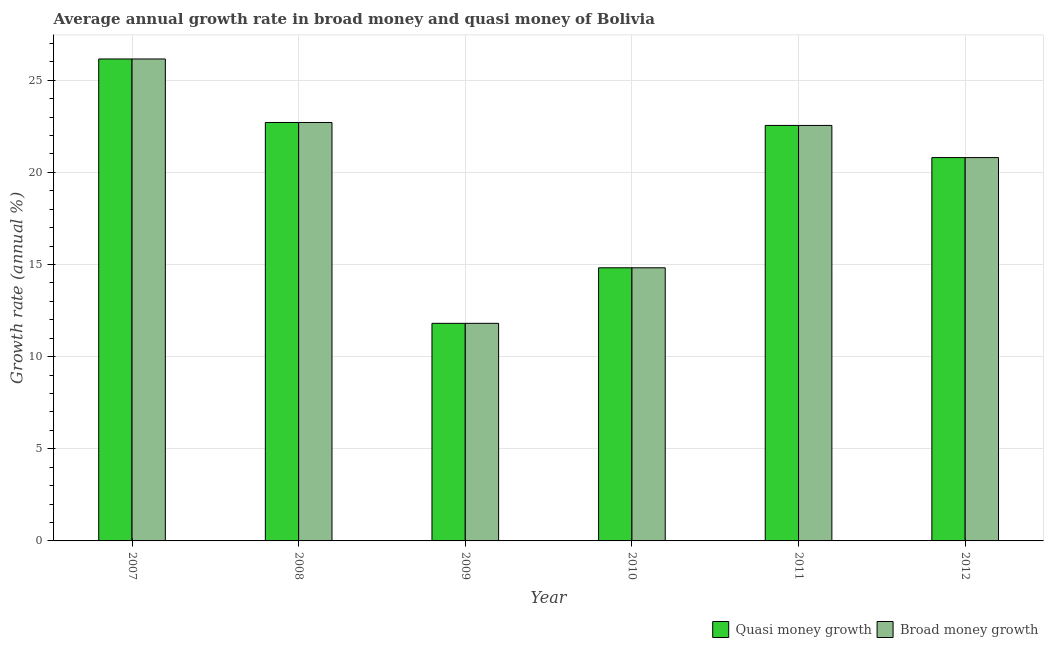How many bars are there on the 5th tick from the left?
Provide a short and direct response. 2. What is the label of the 1st group of bars from the left?
Offer a very short reply. 2007. In how many cases, is the number of bars for a given year not equal to the number of legend labels?
Ensure brevity in your answer.  0. What is the annual growth rate in broad money in 2011?
Offer a terse response. 22.55. Across all years, what is the maximum annual growth rate in quasi money?
Give a very brief answer. 26.15. Across all years, what is the minimum annual growth rate in broad money?
Ensure brevity in your answer.  11.81. In which year was the annual growth rate in broad money minimum?
Give a very brief answer. 2009. What is the total annual growth rate in broad money in the graph?
Keep it short and to the point. 118.83. What is the difference between the annual growth rate in broad money in 2007 and that in 2008?
Your answer should be compact. 3.45. What is the difference between the annual growth rate in quasi money in 2009 and the annual growth rate in broad money in 2007?
Offer a very short reply. -14.34. What is the average annual growth rate in quasi money per year?
Give a very brief answer. 19.8. What is the ratio of the annual growth rate in quasi money in 2009 to that in 2010?
Provide a short and direct response. 0.8. What is the difference between the highest and the second highest annual growth rate in broad money?
Your answer should be very brief. 3.45. What is the difference between the highest and the lowest annual growth rate in quasi money?
Give a very brief answer. 14.34. Is the sum of the annual growth rate in broad money in 2009 and 2010 greater than the maximum annual growth rate in quasi money across all years?
Provide a short and direct response. Yes. What does the 2nd bar from the left in 2010 represents?
Your answer should be compact. Broad money growth. What does the 2nd bar from the right in 2010 represents?
Provide a succinct answer. Quasi money growth. Are all the bars in the graph horizontal?
Your answer should be very brief. No. How many years are there in the graph?
Your answer should be very brief. 6. What is the difference between two consecutive major ticks on the Y-axis?
Provide a succinct answer. 5. Are the values on the major ticks of Y-axis written in scientific E-notation?
Your response must be concise. No. Does the graph contain any zero values?
Offer a very short reply. No. Does the graph contain grids?
Your response must be concise. Yes. How are the legend labels stacked?
Provide a short and direct response. Horizontal. What is the title of the graph?
Your answer should be compact. Average annual growth rate in broad money and quasi money of Bolivia. Does "Import" appear as one of the legend labels in the graph?
Offer a very short reply. No. What is the label or title of the X-axis?
Keep it short and to the point. Year. What is the label or title of the Y-axis?
Provide a succinct answer. Growth rate (annual %). What is the Growth rate (annual %) in Quasi money growth in 2007?
Offer a terse response. 26.15. What is the Growth rate (annual %) of Broad money growth in 2007?
Provide a succinct answer. 26.15. What is the Growth rate (annual %) of Quasi money growth in 2008?
Your answer should be very brief. 22.7. What is the Growth rate (annual %) in Broad money growth in 2008?
Make the answer very short. 22.7. What is the Growth rate (annual %) in Quasi money growth in 2009?
Your answer should be very brief. 11.81. What is the Growth rate (annual %) in Broad money growth in 2009?
Your answer should be compact. 11.81. What is the Growth rate (annual %) of Quasi money growth in 2010?
Give a very brief answer. 14.82. What is the Growth rate (annual %) in Broad money growth in 2010?
Offer a very short reply. 14.82. What is the Growth rate (annual %) in Quasi money growth in 2011?
Make the answer very short. 22.55. What is the Growth rate (annual %) of Broad money growth in 2011?
Your answer should be very brief. 22.55. What is the Growth rate (annual %) in Quasi money growth in 2012?
Your answer should be very brief. 20.8. What is the Growth rate (annual %) of Broad money growth in 2012?
Provide a short and direct response. 20.8. Across all years, what is the maximum Growth rate (annual %) of Quasi money growth?
Your answer should be very brief. 26.15. Across all years, what is the maximum Growth rate (annual %) in Broad money growth?
Ensure brevity in your answer.  26.15. Across all years, what is the minimum Growth rate (annual %) in Quasi money growth?
Your answer should be very brief. 11.81. Across all years, what is the minimum Growth rate (annual %) of Broad money growth?
Give a very brief answer. 11.81. What is the total Growth rate (annual %) in Quasi money growth in the graph?
Provide a short and direct response. 118.83. What is the total Growth rate (annual %) in Broad money growth in the graph?
Keep it short and to the point. 118.83. What is the difference between the Growth rate (annual %) of Quasi money growth in 2007 and that in 2008?
Offer a very short reply. 3.45. What is the difference between the Growth rate (annual %) of Broad money growth in 2007 and that in 2008?
Give a very brief answer. 3.45. What is the difference between the Growth rate (annual %) of Quasi money growth in 2007 and that in 2009?
Make the answer very short. 14.34. What is the difference between the Growth rate (annual %) in Broad money growth in 2007 and that in 2009?
Provide a succinct answer. 14.34. What is the difference between the Growth rate (annual %) in Quasi money growth in 2007 and that in 2010?
Offer a very short reply. 11.33. What is the difference between the Growth rate (annual %) in Broad money growth in 2007 and that in 2010?
Your answer should be compact. 11.33. What is the difference between the Growth rate (annual %) of Quasi money growth in 2007 and that in 2011?
Make the answer very short. 3.61. What is the difference between the Growth rate (annual %) in Broad money growth in 2007 and that in 2011?
Provide a succinct answer. 3.61. What is the difference between the Growth rate (annual %) in Quasi money growth in 2007 and that in 2012?
Offer a very short reply. 5.35. What is the difference between the Growth rate (annual %) in Broad money growth in 2007 and that in 2012?
Your answer should be very brief. 5.35. What is the difference between the Growth rate (annual %) in Quasi money growth in 2008 and that in 2009?
Keep it short and to the point. 10.9. What is the difference between the Growth rate (annual %) of Broad money growth in 2008 and that in 2009?
Your answer should be very brief. 10.9. What is the difference between the Growth rate (annual %) of Quasi money growth in 2008 and that in 2010?
Give a very brief answer. 7.88. What is the difference between the Growth rate (annual %) of Broad money growth in 2008 and that in 2010?
Your answer should be compact. 7.88. What is the difference between the Growth rate (annual %) of Quasi money growth in 2008 and that in 2011?
Keep it short and to the point. 0.16. What is the difference between the Growth rate (annual %) of Broad money growth in 2008 and that in 2011?
Your answer should be very brief. 0.16. What is the difference between the Growth rate (annual %) of Quasi money growth in 2008 and that in 2012?
Provide a short and direct response. 1.9. What is the difference between the Growth rate (annual %) in Broad money growth in 2008 and that in 2012?
Provide a succinct answer. 1.9. What is the difference between the Growth rate (annual %) in Quasi money growth in 2009 and that in 2010?
Your answer should be compact. -3.01. What is the difference between the Growth rate (annual %) in Broad money growth in 2009 and that in 2010?
Your response must be concise. -3.01. What is the difference between the Growth rate (annual %) of Quasi money growth in 2009 and that in 2011?
Ensure brevity in your answer.  -10.74. What is the difference between the Growth rate (annual %) of Broad money growth in 2009 and that in 2011?
Offer a terse response. -10.74. What is the difference between the Growth rate (annual %) in Quasi money growth in 2009 and that in 2012?
Make the answer very short. -8.99. What is the difference between the Growth rate (annual %) in Broad money growth in 2009 and that in 2012?
Ensure brevity in your answer.  -8.99. What is the difference between the Growth rate (annual %) in Quasi money growth in 2010 and that in 2011?
Your answer should be compact. -7.72. What is the difference between the Growth rate (annual %) of Broad money growth in 2010 and that in 2011?
Your response must be concise. -7.72. What is the difference between the Growth rate (annual %) in Quasi money growth in 2010 and that in 2012?
Your answer should be very brief. -5.98. What is the difference between the Growth rate (annual %) in Broad money growth in 2010 and that in 2012?
Make the answer very short. -5.98. What is the difference between the Growth rate (annual %) in Quasi money growth in 2011 and that in 2012?
Ensure brevity in your answer.  1.75. What is the difference between the Growth rate (annual %) of Broad money growth in 2011 and that in 2012?
Offer a very short reply. 1.75. What is the difference between the Growth rate (annual %) in Quasi money growth in 2007 and the Growth rate (annual %) in Broad money growth in 2008?
Make the answer very short. 3.45. What is the difference between the Growth rate (annual %) in Quasi money growth in 2007 and the Growth rate (annual %) in Broad money growth in 2009?
Make the answer very short. 14.34. What is the difference between the Growth rate (annual %) of Quasi money growth in 2007 and the Growth rate (annual %) of Broad money growth in 2010?
Offer a terse response. 11.33. What is the difference between the Growth rate (annual %) in Quasi money growth in 2007 and the Growth rate (annual %) in Broad money growth in 2011?
Your answer should be compact. 3.61. What is the difference between the Growth rate (annual %) of Quasi money growth in 2007 and the Growth rate (annual %) of Broad money growth in 2012?
Make the answer very short. 5.35. What is the difference between the Growth rate (annual %) in Quasi money growth in 2008 and the Growth rate (annual %) in Broad money growth in 2009?
Your answer should be compact. 10.9. What is the difference between the Growth rate (annual %) in Quasi money growth in 2008 and the Growth rate (annual %) in Broad money growth in 2010?
Provide a succinct answer. 7.88. What is the difference between the Growth rate (annual %) in Quasi money growth in 2008 and the Growth rate (annual %) in Broad money growth in 2011?
Offer a very short reply. 0.16. What is the difference between the Growth rate (annual %) in Quasi money growth in 2008 and the Growth rate (annual %) in Broad money growth in 2012?
Keep it short and to the point. 1.9. What is the difference between the Growth rate (annual %) in Quasi money growth in 2009 and the Growth rate (annual %) in Broad money growth in 2010?
Provide a succinct answer. -3.01. What is the difference between the Growth rate (annual %) of Quasi money growth in 2009 and the Growth rate (annual %) of Broad money growth in 2011?
Provide a short and direct response. -10.74. What is the difference between the Growth rate (annual %) in Quasi money growth in 2009 and the Growth rate (annual %) in Broad money growth in 2012?
Your answer should be very brief. -8.99. What is the difference between the Growth rate (annual %) in Quasi money growth in 2010 and the Growth rate (annual %) in Broad money growth in 2011?
Keep it short and to the point. -7.72. What is the difference between the Growth rate (annual %) in Quasi money growth in 2010 and the Growth rate (annual %) in Broad money growth in 2012?
Make the answer very short. -5.98. What is the difference between the Growth rate (annual %) of Quasi money growth in 2011 and the Growth rate (annual %) of Broad money growth in 2012?
Provide a short and direct response. 1.75. What is the average Growth rate (annual %) in Quasi money growth per year?
Keep it short and to the point. 19.8. What is the average Growth rate (annual %) in Broad money growth per year?
Ensure brevity in your answer.  19.8. In the year 2009, what is the difference between the Growth rate (annual %) in Quasi money growth and Growth rate (annual %) in Broad money growth?
Keep it short and to the point. 0. In the year 2012, what is the difference between the Growth rate (annual %) in Quasi money growth and Growth rate (annual %) in Broad money growth?
Your answer should be very brief. 0. What is the ratio of the Growth rate (annual %) in Quasi money growth in 2007 to that in 2008?
Keep it short and to the point. 1.15. What is the ratio of the Growth rate (annual %) in Broad money growth in 2007 to that in 2008?
Provide a short and direct response. 1.15. What is the ratio of the Growth rate (annual %) in Quasi money growth in 2007 to that in 2009?
Keep it short and to the point. 2.21. What is the ratio of the Growth rate (annual %) in Broad money growth in 2007 to that in 2009?
Your answer should be very brief. 2.21. What is the ratio of the Growth rate (annual %) of Quasi money growth in 2007 to that in 2010?
Offer a terse response. 1.76. What is the ratio of the Growth rate (annual %) in Broad money growth in 2007 to that in 2010?
Ensure brevity in your answer.  1.76. What is the ratio of the Growth rate (annual %) in Quasi money growth in 2007 to that in 2011?
Your answer should be compact. 1.16. What is the ratio of the Growth rate (annual %) in Broad money growth in 2007 to that in 2011?
Your answer should be very brief. 1.16. What is the ratio of the Growth rate (annual %) in Quasi money growth in 2007 to that in 2012?
Provide a short and direct response. 1.26. What is the ratio of the Growth rate (annual %) in Broad money growth in 2007 to that in 2012?
Offer a very short reply. 1.26. What is the ratio of the Growth rate (annual %) of Quasi money growth in 2008 to that in 2009?
Provide a succinct answer. 1.92. What is the ratio of the Growth rate (annual %) of Broad money growth in 2008 to that in 2009?
Give a very brief answer. 1.92. What is the ratio of the Growth rate (annual %) in Quasi money growth in 2008 to that in 2010?
Offer a terse response. 1.53. What is the ratio of the Growth rate (annual %) in Broad money growth in 2008 to that in 2010?
Your answer should be compact. 1.53. What is the ratio of the Growth rate (annual %) of Quasi money growth in 2008 to that in 2011?
Offer a very short reply. 1.01. What is the ratio of the Growth rate (annual %) in Broad money growth in 2008 to that in 2011?
Ensure brevity in your answer.  1.01. What is the ratio of the Growth rate (annual %) of Quasi money growth in 2008 to that in 2012?
Your response must be concise. 1.09. What is the ratio of the Growth rate (annual %) of Broad money growth in 2008 to that in 2012?
Your answer should be compact. 1.09. What is the ratio of the Growth rate (annual %) in Quasi money growth in 2009 to that in 2010?
Make the answer very short. 0.8. What is the ratio of the Growth rate (annual %) in Broad money growth in 2009 to that in 2010?
Your response must be concise. 0.8. What is the ratio of the Growth rate (annual %) of Quasi money growth in 2009 to that in 2011?
Give a very brief answer. 0.52. What is the ratio of the Growth rate (annual %) of Broad money growth in 2009 to that in 2011?
Offer a terse response. 0.52. What is the ratio of the Growth rate (annual %) in Quasi money growth in 2009 to that in 2012?
Offer a terse response. 0.57. What is the ratio of the Growth rate (annual %) in Broad money growth in 2009 to that in 2012?
Provide a short and direct response. 0.57. What is the ratio of the Growth rate (annual %) of Quasi money growth in 2010 to that in 2011?
Give a very brief answer. 0.66. What is the ratio of the Growth rate (annual %) in Broad money growth in 2010 to that in 2011?
Give a very brief answer. 0.66. What is the ratio of the Growth rate (annual %) in Quasi money growth in 2010 to that in 2012?
Ensure brevity in your answer.  0.71. What is the ratio of the Growth rate (annual %) of Broad money growth in 2010 to that in 2012?
Keep it short and to the point. 0.71. What is the ratio of the Growth rate (annual %) in Quasi money growth in 2011 to that in 2012?
Offer a very short reply. 1.08. What is the ratio of the Growth rate (annual %) of Broad money growth in 2011 to that in 2012?
Your answer should be very brief. 1.08. What is the difference between the highest and the second highest Growth rate (annual %) in Quasi money growth?
Provide a short and direct response. 3.45. What is the difference between the highest and the second highest Growth rate (annual %) of Broad money growth?
Offer a terse response. 3.45. What is the difference between the highest and the lowest Growth rate (annual %) of Quasi money growth?
Your answer should be very brief. 14.34. What is the difference between the highest and the lowest Growth rate (annual %) of Broad money growth?
Give a very brief answer. 14.34. 